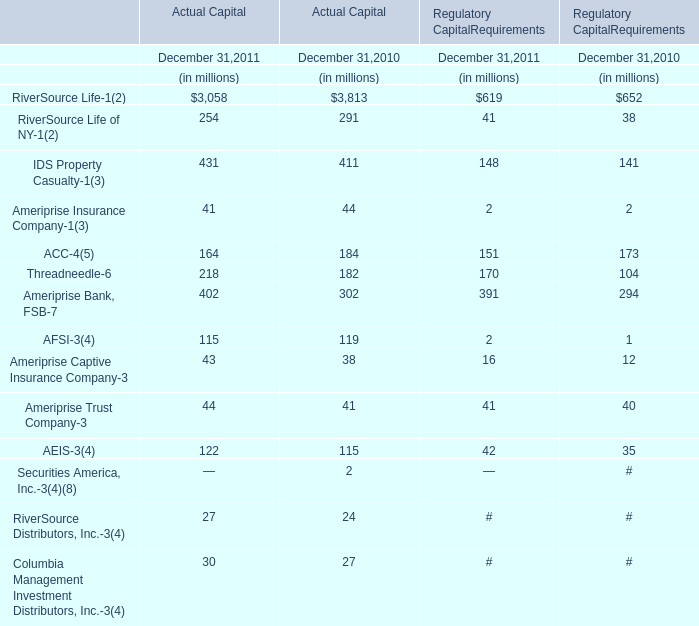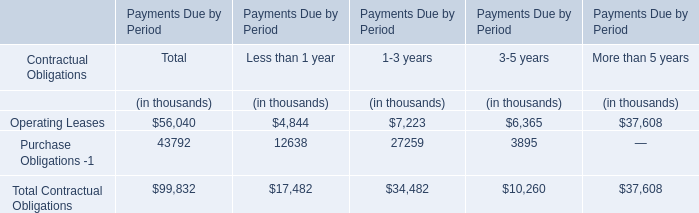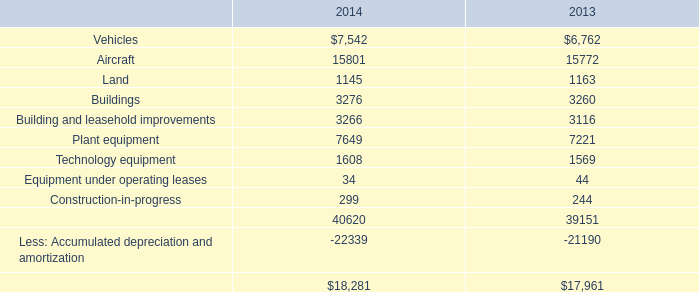What's the growth rate of IDS Property Casualty of Actual Capital in 2011? 
Computations: ((431 - 411) / 411)
Answer: 0.04866. 